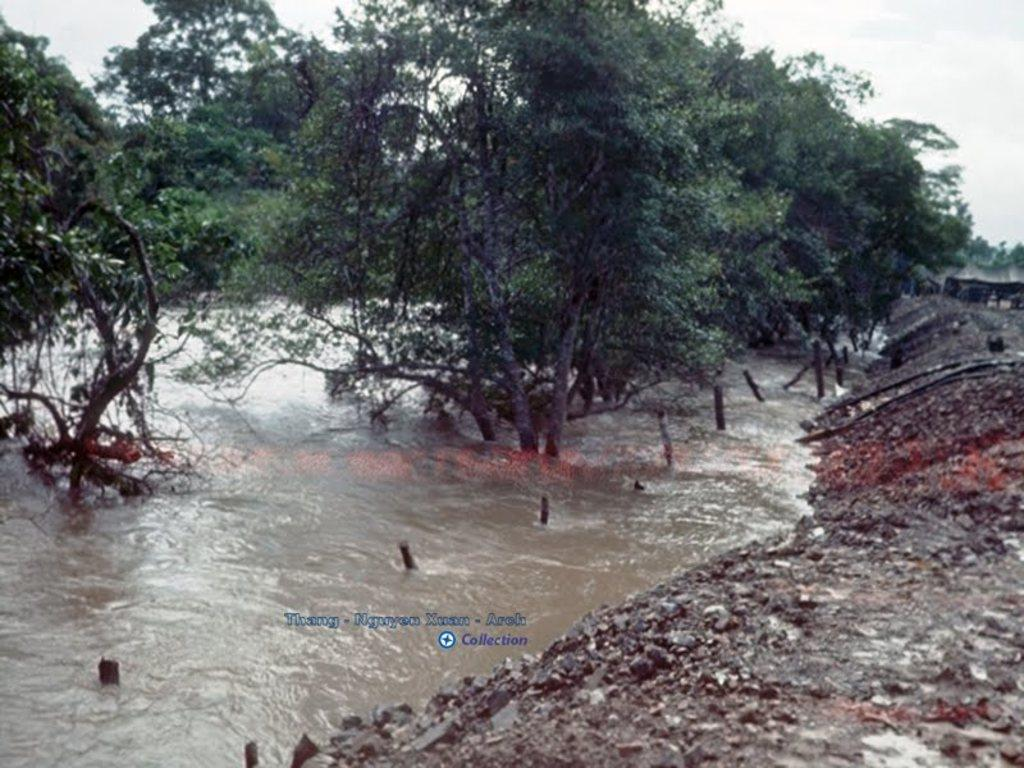What is visible in the image? There is water and trees visible in the image. What is the color of the trees? The trees are green in color. What is the color of the sky in the image? The sky is white in color. What brand of toothpaste is being advertised in the image? There is no toothpaste or advertisement present in the image. How many hands are visible in the image? There are no hands visible in the image. 